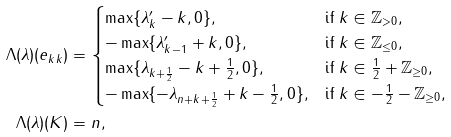Convert formula to latex. <formula><loc_0><loc_0><loc_500><loc_500>\Lambda ( \lambda ) ( e _ { k k } ) & = \begin{cases} \max \{ \lambda ^ { \prime } _ { k } - k , 0 \} , & \text {if $k\in\mathbb{Z}_{> 0}$} , \\ - \max \{ \lambda ^ { \prime } _ { k - 1 } + k , 0 \} , & \text {if $k\in\mathbb{Z}_{\leq 0}$} , \\ \max \{ \lambda _ { k + \frac { 1 } { 2 } } - k + \frac { 1 } { 2 } , 0 \} , & \text {if $k\in\frac{1}{2}+\mathbb{Z}_{\geq 0}$} , \\ - \max \{ - \lambda _ { n + k + \frac { 1 } { 2 } } + k - \frac { 1 } { 2 } , 0 \} , & \text {if $k\in -\frac{1}{2}-\mathbb{Z}_{\geq 0}$} , \\ \end{cases} \\ \Lambda ( \lambda ) ( K ) & = n ,</formula> 